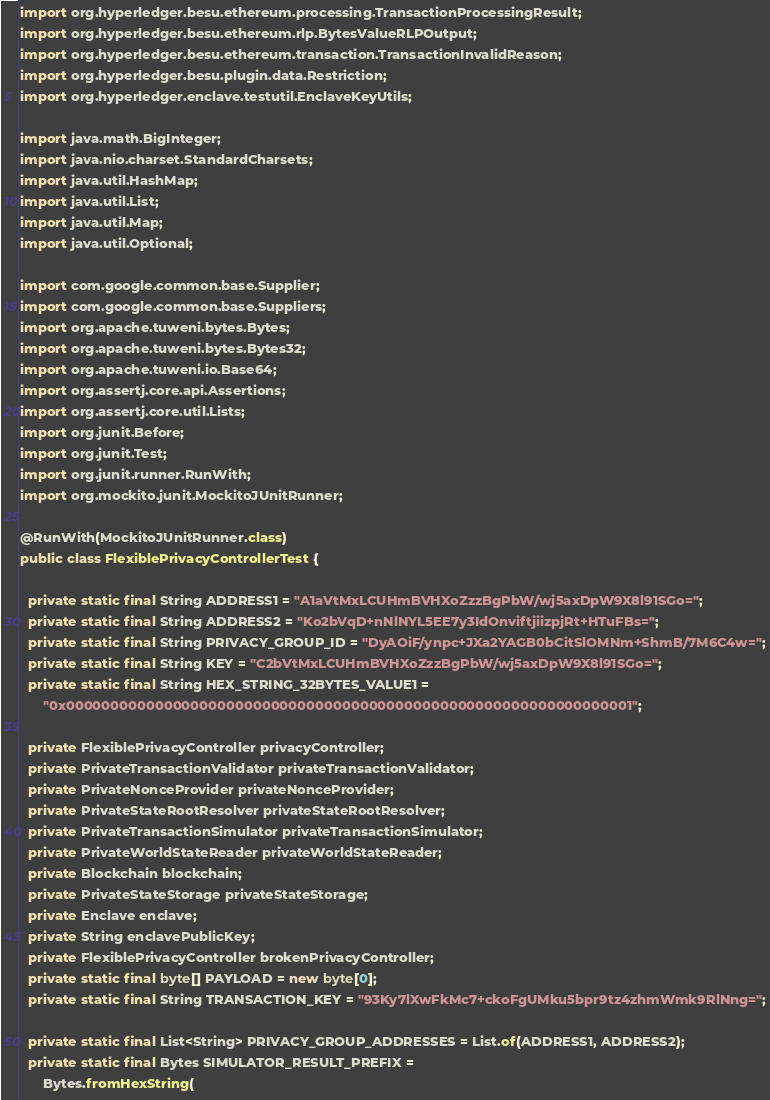Convert code to text. <code><loc_0><loc_0><loc_500><loc_500><_Java_>import org.hyperledger.besu.ethereum.processing.TransactionProcessingResult;
import org.hyperledger.besu.ethereum.rlp.BytesValueRLPOutput;
import org.hyperledger.besu.ethereum.transaction.TransactionInvalidReason;
import org.hyperledger.besu.plugin.data.Restriction;
import org.hyperledger.enclave.testutil.EnclaveKeyUtils;

import java.math.BigInteger;
import java.nio.charset.StandardCharsets;
import java.util.HashMap;
import java.util.List;
import java.util.Map;
import java.util.Optional;

import com.google.common.base.Supplier;
import com.google.common.base.Suppliers;
import org.apache.tuweni.bytes.Bytes;
import org.apache.tuweni.bytes.Bytes32;
import org.apache.tuweni.io.Base64;
import org.assertj.core.api.Assertions;
import org.assertj.core.util.Lists;
import org.junit.Before;
import org.junit.Test;
import org.junit.runner.RunWith;
import org.mockito.junit.MockitoJUnitRunner;

@RunWith(MockitoJUnitRunner.class)
public class FlexiblePrivacyControllerTest {

  private static final String ADDRESS1 = "A1aVtMxLCUHmBVHXoZzzBgPbW/wj5axDpW9X8l91SGo=";
  private static final String ADDRESS2 = "Ko2bVqD+nNlNYL5EE7y3IdOnviftjiizpjRt+HTuFBs=";
  private static final String PRIVACY_GROUP_ID = "DyAOiF/ynpc+JXa2YAGB0bCitSlOMNm+ShmB/7M6C4w=";
  private static final String KEY = "C2bVtMxLCUHmBVHXoZzzBgPbW/wj5axDpW9X8l91SGo=";
  private static final String HEX_STRING_32BYTES_VALUE1 =
      "0x0000000000000000000000000000000000000000000000000000000000000001";

  private FlexiblePrivacyController privacyController;
  private PrivateTransactionValidator privateTransactionValidator;
  private PrivateNonceProvider privateNonceProvider;
  private PrivateStateRootResolver privateStateRootResolver;
  private PrivateTransactionSimulator privateTransactionSimulator;
  private PrivateWorldStateReader privateWorldStateReader;
  private Blockchain blockchain;
  private PrivateStateStorage privateStateStorage;
  private Enclave enclave;
  private String enclavePublicKey;
  private FlexiblePrivacyController brokenPrivacyController;
  private static final byte[] PAYLOAD = new byte[0];
  private static final String TRANSACTION_KEY = "93Ky7lXwFkMc7+ckoFgUMku5bpr9tz4zhmWmk9RlNng=";

  private static final List<String> PRIVACY_GROUP_ADDRESSES = List.of(ADDRESS1, ADDRESS2);
  private static final Bytes SIMULATOR_RESULT_PREFIX =
      Bytes.fromHexString(</code> 